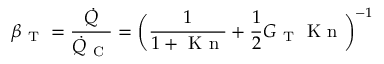Convert formula to latex. <formula><loc_0><loc_0><loc_500><loc_500>\beta _ { T } = \frac { \dot { Q } } { \dot { Q } _ { C } } = \left ( \frac { 1 } { 1 + K n } + \frac { 1 } { 2 } G _ { T } K n \right ) ^ { - 1 }</formula> 